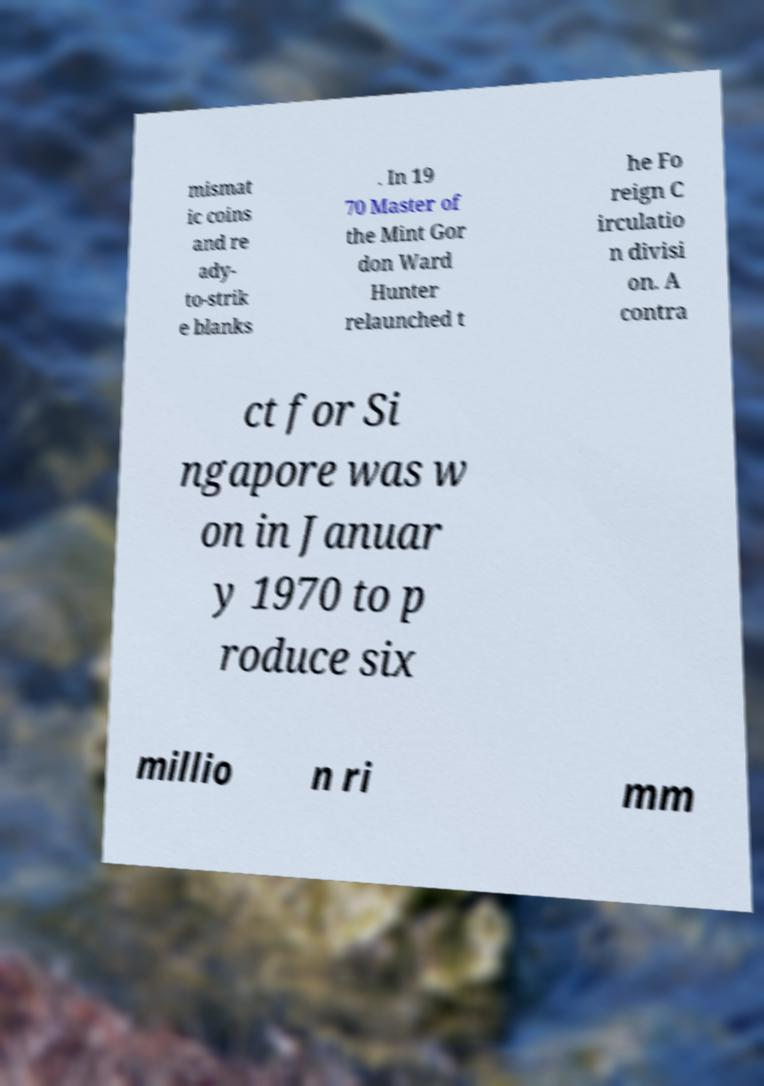Please read and relay the text visible in this image. What does it say? mismat ic coins and re ady- to-strik e blanks . In 19 70 Master of the Mint Gor don Ward Hunter relaunched t he Fo reign C irculatio n divisi on. A contra ct for Si ngapore was w on in Januar y 1970 to p roduce six millio n ri mm 